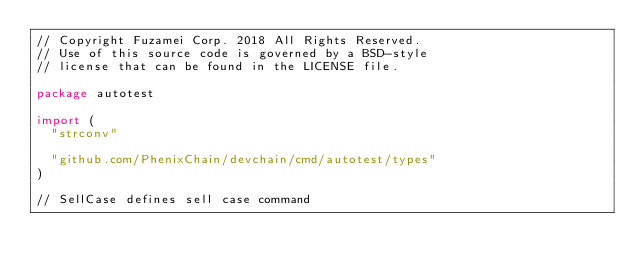Convert code to text. <code><loc_0><loc_0><loc_500><loc_500><_Go_>// Copyright Fuzamei Corp. 2018 All Rights Reserved.
// Use of this source code is governed by a BSD-style
// license that can be found in the LICENSE file.

package autotest

import (
	"strconv"

	"github.com/PhenixChain/devchain/cmd/autotest/types"
)

// SellCase defines sell case command</code> 